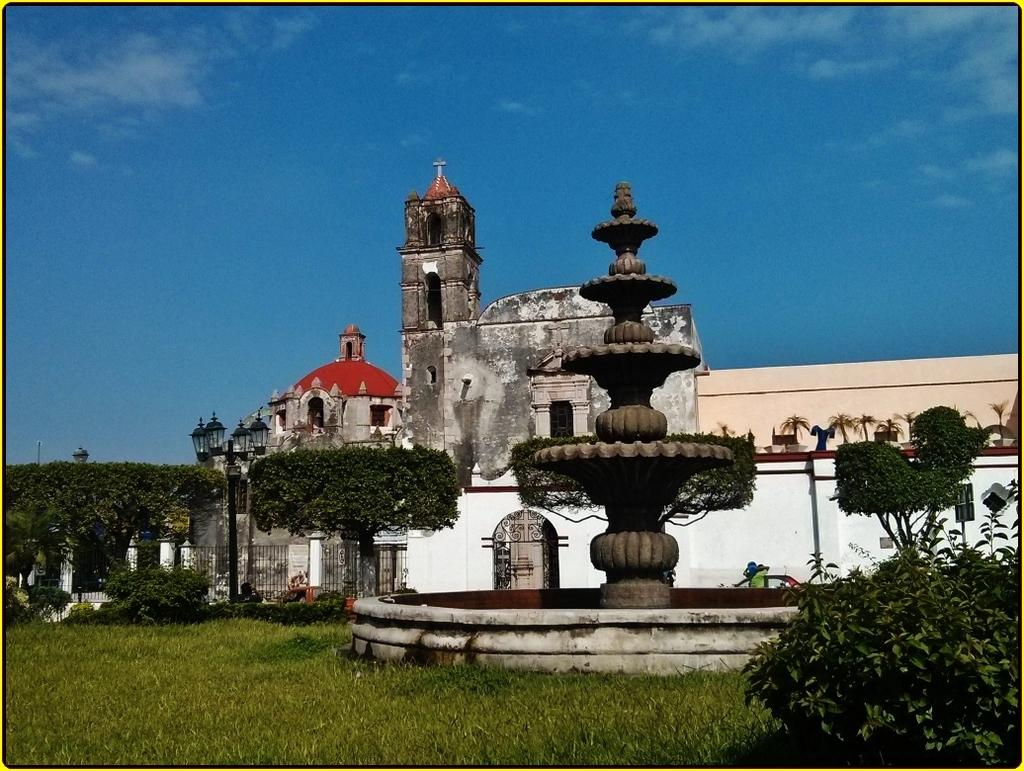What type of vegetation is present in the image? There is grass and trees in the image. What other plants can be seen in the image? There are house plants in the image. What water feature is present in the image? There is a fountain in the image. What type of structure is visible in the image? There are buildings and a mosque in the image. What architectural element can be seen in the image? There is a fence in the image. What type of lighting is present in the image? There are lamps in the image. What part of the natural environment is visible in the image? The sky is visible in the image. How many pizzas are being served on the arm in the image? There are no pizzas or arms present in the image. 